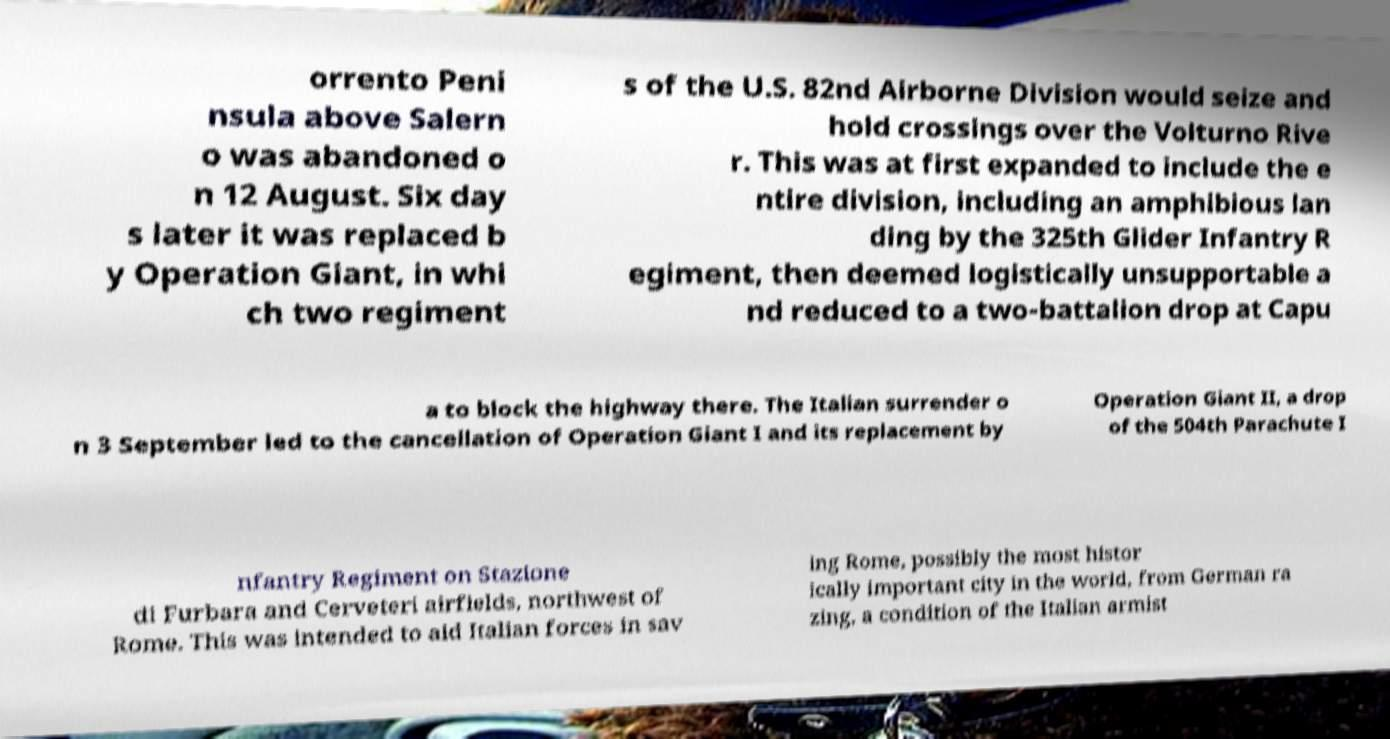Please identify and transcribe the text found in this image. orrento Peni nsula above Salern o was abandoned o n 12 August. Six day s later it was replaced b y Operation Giant, in whi ch two regiment s of the U.S. 82nd Airborne Division would seize and hold crossings over the Volturno Rive r. This was at first expanded to include the e ntire division, including an amphibious lan ding by the 325th Glider Infantry R egiment, then deemed logistically unsupportable a nd reduced to a two-battalion drop at Capu a to block the highway there. The Italian surrender o n 3 September led to the cancellation of Operation Giant I and its replacement by Operation Giant II, a drop of the 504th Parachute I nfantry Regiment on Stazione di Furbara and Cerveteri airfields, northwest of Rome. This was intended to aid Italian forces in sav ing Rome, possibly the most histor ically important city in the world, from German ra zing, a condition of the Italian armist 